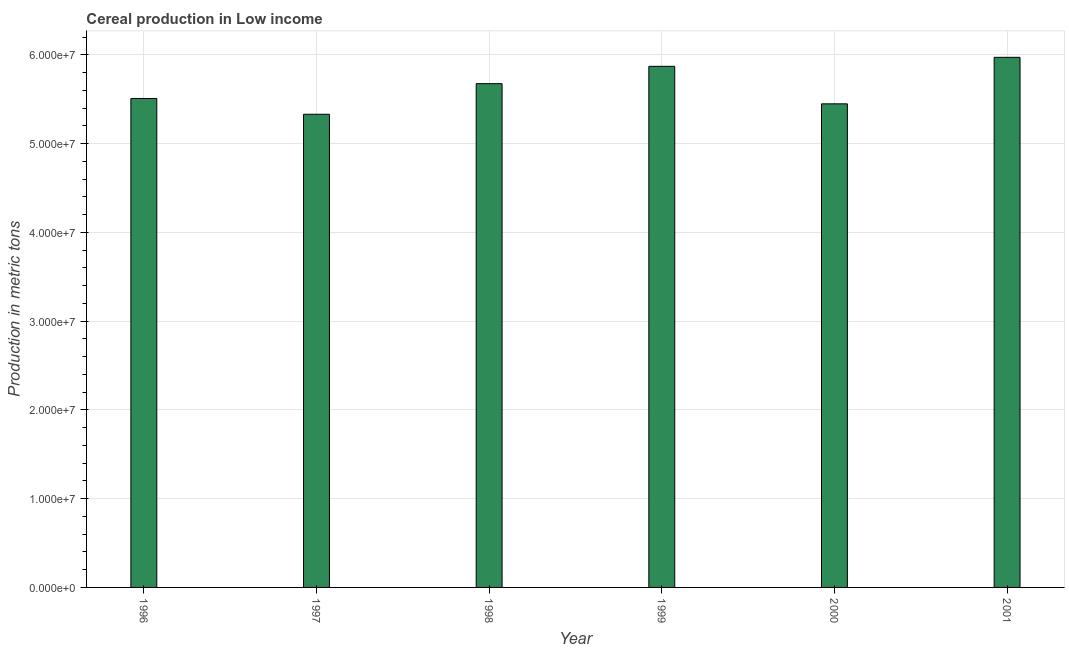What is the title of the graph?
Provide a succinct answer. Cereal production in Low income. What is the label or title of the X-axis?
Offer a terse response. Year. What is the label or title of the Y-axis?
Ensure brevity in your answer.  Production in metric tons. What is the cereal production in 1996?
Provide a short and direct response. 5.51e+07. Across all years, what is the maximum cereal production?
Your answer should be very brief. 5.97e+07. Across all years, what is the minimum cereal production?
Offer a very short reply. 5.33e+07. In which year was the cereal production maximum?
Make the answer very short. 2001. In which year was the cereal production minimum?
Provide a short and direct response. 1997. What is the sum of the cereal production?
Provide a short and direct response. 3.38e+08. What is the difference between the cereal production in 1997 and 1999?
Your answer should be very brief. -5.40e+06. What is the average cereal production per year?
Your answer should be compact. 5.63e+07. What is the median cereal production?
Make the answer very short. 5.59e+07. What is the ratio of the cereal production in 1998 to that in 1999?
Give a very brief answer. 0.97. Is the cereal production in 2000 less than that in 2001?
Provide a short and direct response. Yes. Is the difference between the cereal production in 1996 and 1997 greater than the difference between any two years?
Provide a succinct answer. No. What is the difference between the highest and the second highest cereal production?
Your answer should be very brief. 1.01e+06. What is the difference between the highest and the lowest cereal production?
Keep it short and to the point. 6.42e+06. In how many years, is the cereal production greater than the average cereal production taken over all years?
Your answer should be compact. 3. How many bars are there?
Provide a short and direct response. 6. Are all the bars in the graph horizontal?
Your answer should be very brief. No. Are the values on the major ticks of Y-axis written in scientific E-notation?
Keep it short and to the point. Yes. What is the Production in metric tons of 1996?
Keep it short and to the point. 5.51e+07. What is the Production in metric tons of 1997?
Your answer should be very brief. 5.33e+07. What is the Production in metric tons of 1998?
Keep it short and to the point. 5.68e+07. What is the Production in metric tons of 1999?
Offer a very short reply. 5.87e+07. What is the Production in metric tons in 2000?
Your answer should be compact. 5.45e+07. What is the Production in metric tons in 2001?
Make the answer very short. 5.97e+07. What is the difference between the Production in metric tons in 1996 and 1997?
Provide a short and direct response. 1.78e+06. What is the difference between the Production in metric tons in 1996 and 1998?
Your answer should be very brief. -1.67e+06. What is the difference between the Production in metric tons in 1996 and 1999?
Your answer should be compact. -3.62e+06. What is the difference between the Production in metric tons in 1996 and 2000?
Your answer should be very brief. 6.02e+05. What is the difference between the Production in metric tons in 1996 and 2001?
Your answer should be compact. -4.64e+06. What is the difference between the Production in metric tons in 1997 and 1998?
Your answer should be compact. -3.45e+06. What is the difference between the Production in metric tons in 1997 and 1999?
Provide a short and direct response. -5.40e+06. What is the difference between the Production in metric tons in 1997 and 2000?
Offer a very short reply. -1.18e+06. What is the difference between the Production in metric tons in 1997 and 2001?
Make the answer very short. -6.42e+06. What is the difference between the Production in metric tons in 1998 and 1999?
Provide a succinct answer. -1.95e+06. What is the difference between the Production in metric tons in 1998 and 2000?
Ensure brevity in your answer.  2.27e+06. What is the difference between the Production in metric tons in 1998 and 2001?
Your answer should be compact. -2.97e+06. What is the difference between the Production in metric tons in 1999 and 2000?
Make the answer very short. 4.23e+06. What is the difference between the Production in metric tons in 1999 and 2001?
Provide a short and direct response. -1.01e+06. What is the difference between the Production in metric tons in 2000 and 2001?
Make the answer very short. -5.24e+06. What is the ratio of the Production in metric tons in 1996 to that in 1997?
Your answer should be very brief. 1.03. What is the ratio of the Production in metric tons in 1996 to that in 1998?
Offer a very short reply. 0.97. What is the ratio of the Production in metric tons in 1996 to that in 1999?
Ensure brevity in your answer.  0.94. What is the ratio of the Production in metric tons in 1996 to that in 2001?
Your response must be concise. 0.92. What is the ratio of the Production in metric tons in 1997 to that in 1998?
Your answer should be very brief. 0.94. What is the ratio of the Production in metric tons in 1997 to that in 1999?
Keep it short and to the point. 0.91. What is the ratio of the Production in metric tons in 1997 to that in 2000?
Your answer should be very brief. 0.98. What is the ratio of the Production in metric tons in 1997 to that in 2001?
Your response must be concise. 0.89. What is the ratio of the Production in metric tons in 1998 to that in 2000?
Keep it short and to the point. 1.04. What is the ratio of the Production in metric tons in 1999 to that in 2000?
Provide a short and direct response. 1.08. What is the ratio of the Production in metric tons in 2000 to that in 2001?
Keep it short and to the point. 0.91. 